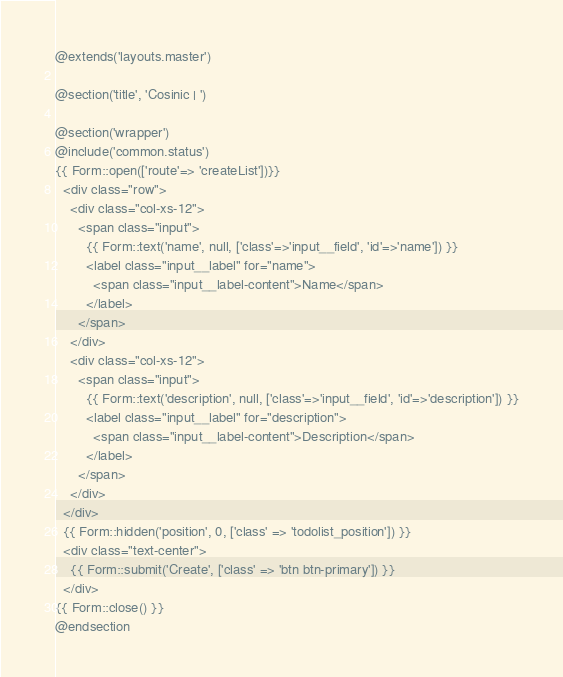<code> <loc_0><loc_0><loc_500><loc_500><_PHP_>@extends('layouts.master')

@section('title', 'Cosinic | ')

@section('wrapper')
@include('common.status')
{{ Form::open(['route'=> 'createList'])}}
  <div class="row">
    <div class="col-xs-12">
      <span class="input">
        {{ Form::text('name', null, ['class'=>'input__field', 'id'=>'name']) }}
        <label class="input__label" for="name">
          <span class="input__label-content">Name</span>
        </label>
      </span>
    </div>
    <div class="col-xs-12">
      <span class="input">
        {{ Form::text('description', null, ['class'=>'input__field', 'id'=>'description']) }}
        <label class="input__label" for="description">
          <span class="input__label-content">Description</span>
        </label>
      </span>
    </div>
  </div>
  {{ Form::hidden('position', 0, ['class' => 'todolist_position']) }}
  <div class="text-center">
    {{ Form::submit('Create', ['class' => 'btn btn-primary']) }}
  </div>
{{ Form::close() }}
@endsection
</code> 